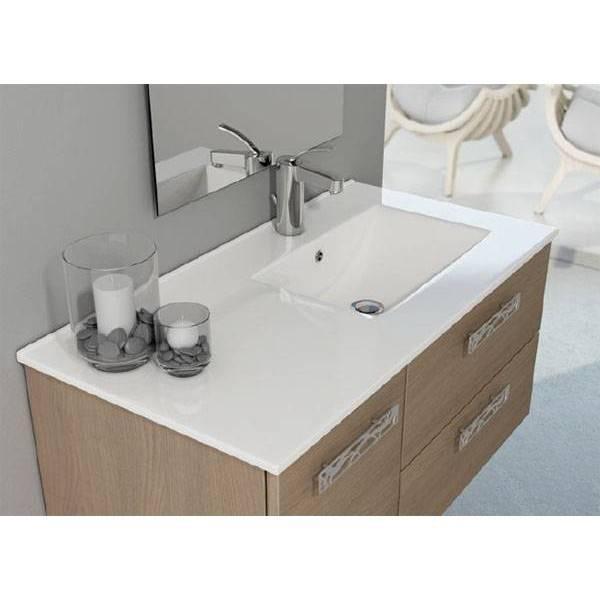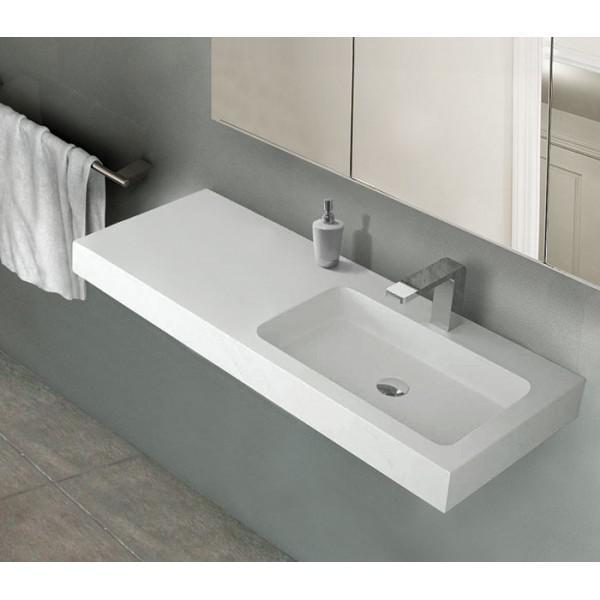The first image is the image on the left, the second image is the image on the right. Assess this claim about the two images: "A vanity includes one rectangular white sink and a brown cabinet with multiple drawers.". Correct or not? Answer yes or no. Yes. The first image is the image on the left, the second image is the image on the right. Examine the images to the left and right. Is the description "In at least one image, a mirror is clearly visible above a bathroom sink" accurate? Answer yes or no. Yes. 